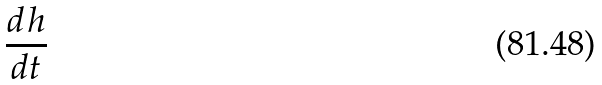<formula> <loc_0><loc_0><loc_500><loc_500>\frac { d h } { d t }</formula> 